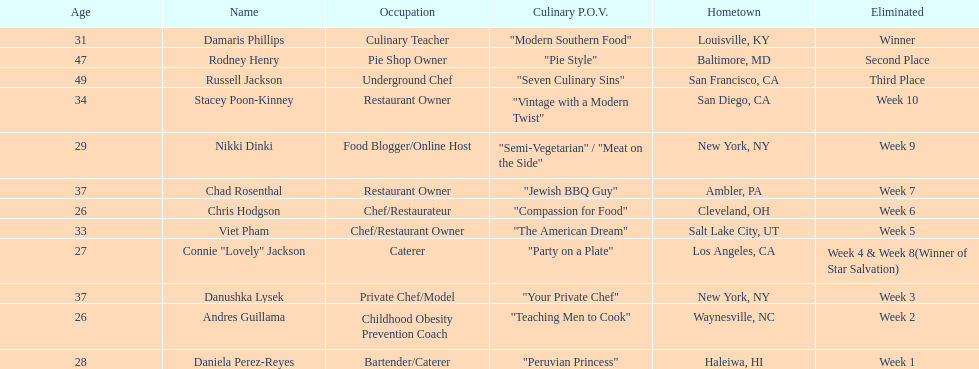In the case of nikki dinki and viet pham, which one was eliminated first? Viet Pham. 